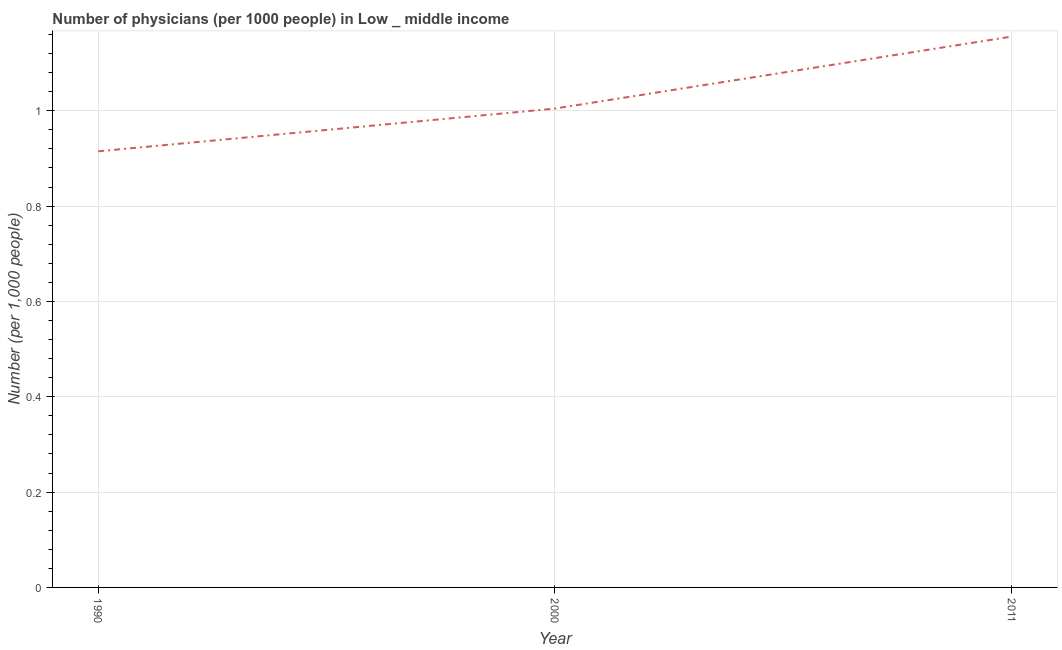What is the number of physicians in 2000?
Offer a terse response. 1. Across all years, what is the maximum number of physicians?
Offer a very short reply. 1.16. Across all years, what is the minimum number of physicians?
Ensure brevity in your answer.  0.91. In which year was the number of physicians maximum?
Offer a terse response. 2011. In which year was the number of physicians minimum?
Give a very brief answer. 1990. What is the sum of the number of physicians?
Ensure brevity in your answer.  3.08. What is the difference between the number of physicians in 2000 and 2011?
Make the answer very short. -0.15. What is the average number of physicians per year?
Your answer should be compact. 1.03. What is the median number of physicians?
Make the answer very short. 1. In how many years, is the number of physicians greater than 0.8400000000000001 ?
Your answer should be compact. 3. Do a majority of the years between 2011 and 2000 (inclusive) have number of physicians greater than 0.32 ?
Ensure brevity in your answer.  No. What is the ratio of the number of physicians in 2000 to that in 2011?
Your answer should be very brief. 0.87. Is the difference between the number of physicians in 1990 and 2011 greater than the difference between any two years?
Make the answer very short. Yes. What is the difference between the highest and the second highest number of physicians?
Offer a very short reply. 0.15. Is the sum of the number of physicians in 2000 and 2011 greater than the maximum number of physicians across all years?
Give a very brief answer. Yes. What is the difference between the highest and the lowest number of physicians?
Provide a short and direct response. 0.24. In how many years, is the number of physicians greater than the average number of physicians taken over all years?
Make the answer very short. 1. Does the number of physicians monotonically increase over the years?
Keep it short and to the point. Yes. Are the values on the major ticks of Y-axis written in scientific E-notation?
Your answer should be compact. No. Does the graph contain any zero values?
Your answer should be very brief. No. Does the graph contain grids?
Provide a short and direct response. Yes. What is the title of the graph?
Offer a terse response. Number of physicians (per 1000 people) in Low _ middle income. What is the label or title of the Y-axis?
Provide a succinct answer. Number (per 1,0 people). What is the Number (per 1,000 people) of 1990?
Provide a short and direct response. 0.91. What is the Number (per 1,000 people) in 2000?
Offer a very short reply. 1. What is the Number (per 1,000 people) in 2011?
Provide a short and direct response. 1.16. What is the difference between the Number (per 1,000 people) in 1990 and 2000?
Provide a succinct answer. -0.09. What is the difference between the Number (per 1,000 people) in 1990 and 2011?
Ensure brevity in your answer.  -0.24. What is the difference between the Number (per 1,000 people) in 2000 and 2011?
Offer a very short reply. -0.15. What is the ratio of the Number (per 1,000 people) in 1990 to that in 2000?
Offer a very short reply. 0.91. What is the ratio of the Number (per 1,000 people) in 1990 to that in 2011?
Provide a short and direct response. 0.79. What is the ratio of the Number (per 1,000 people) in 2000 to that in 2011?
Provide a succinct answer. 0.87. 